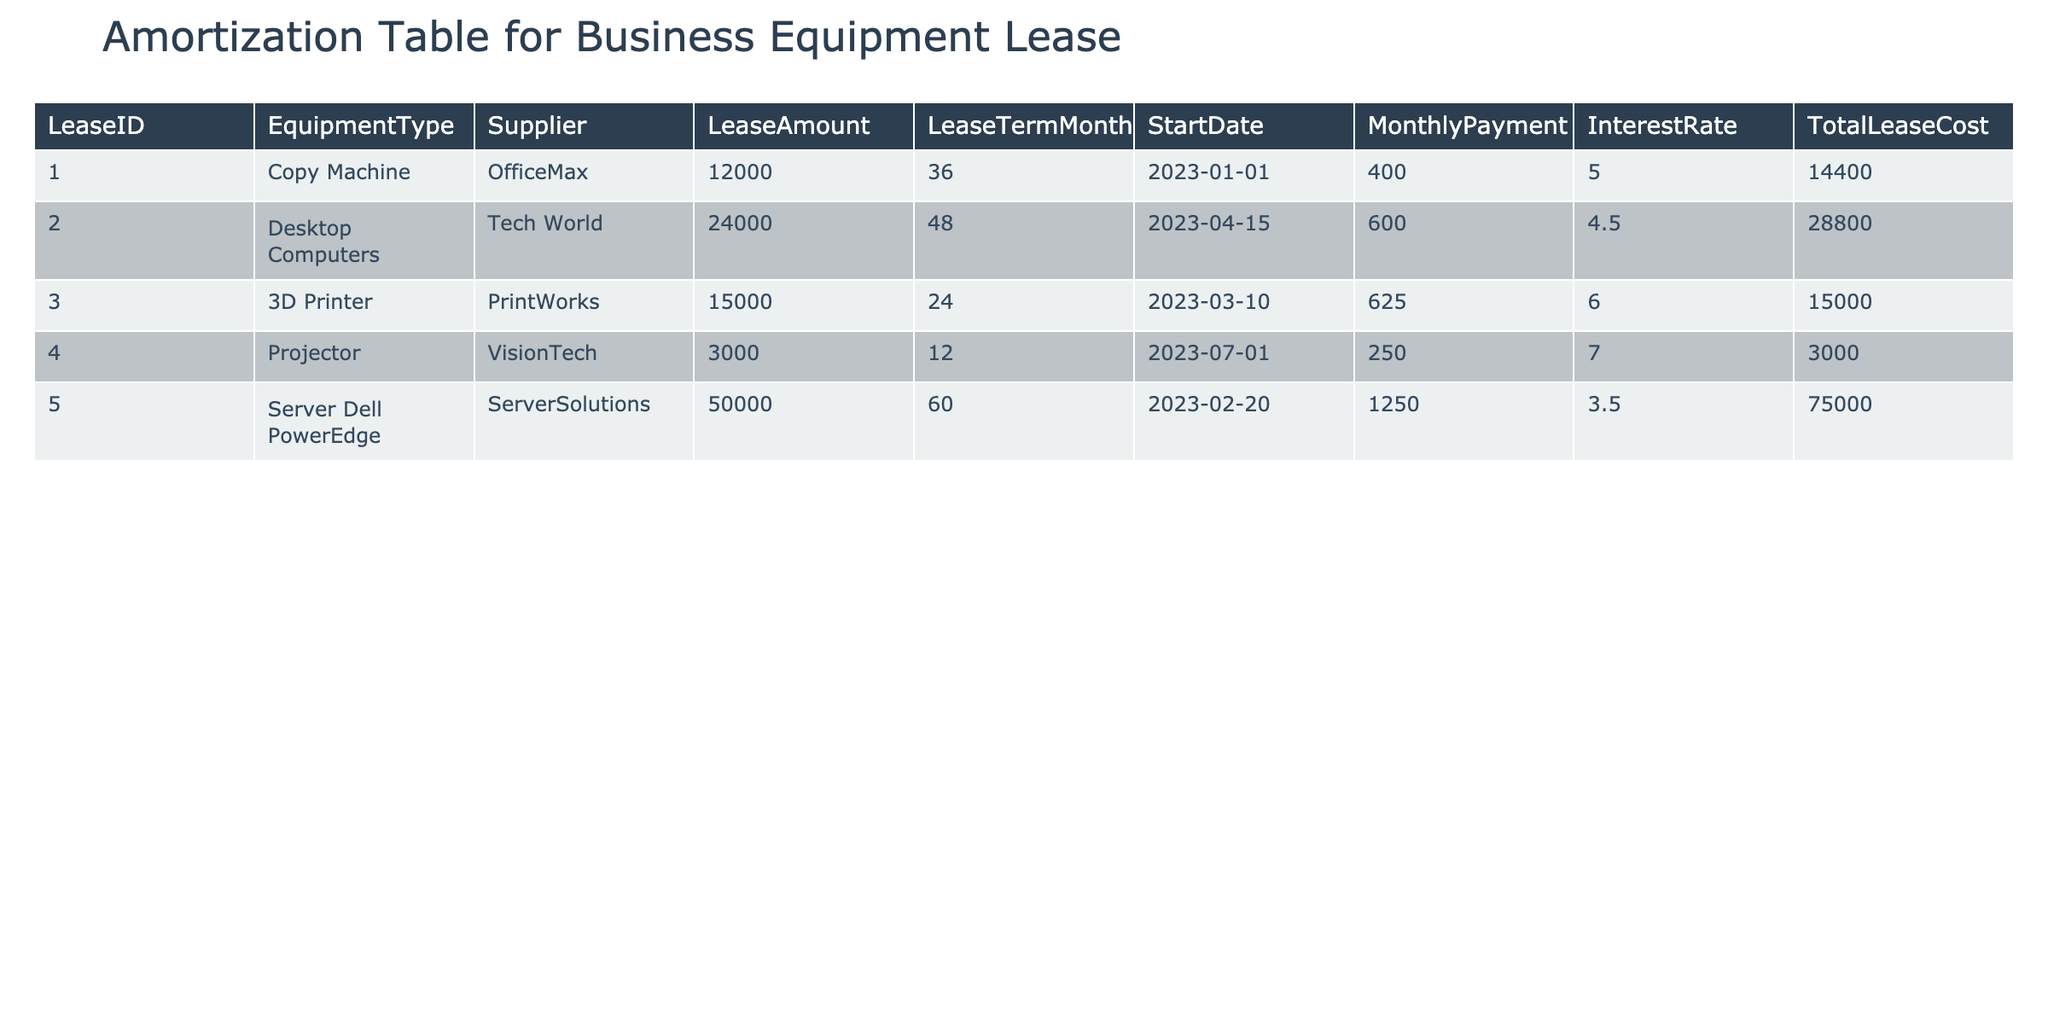What is the total lease cost for the Copy Machine? The total lease cost for the Copy Machine corresponds to LeaseID 1, which is specified in the table as 14400.
Answer: 14400 What is the monthly payment for the Server Dell PowerEdge lease? The monthly payment for the Server Dell PowerEdge is listed under LeaseID 5, which is 1250.
Answer: 1250 Which equipment type has the longest lease term? To find the longest lease term, we look through the LeaseTermMonths column. The maximum value is 60 months for the Server Dell PowerEdge.
Answer: Server Dell PowerEdge Is the interest rate for the Desktop Computers higher than 5%? The interest rate for the Desktop Computers, as per LeaseID 2, is 4.5%, which is less than 5%.
Answer: No What is the average monthly payment for all leases? First, we sum the monthly payments: 400 + 600 + 625 + 250 + 1250 = 3125. Then, divide by the number of leases, which is 5: 3125 / 5 = 625.
Answer: 625 How much total lease cost do the four items with the lowest total lease costs have? The items with the lowest total lease costs are the Projector (3000), the 3D Printer (15000), the Copy Machine (14400), and the Desktop Computers (28800). Adding these together: 3000 + 15000 + 14400 + 28800 = 61200.
Answer: 61200 Is the monthly payment for the equipment with the second highest total lease cost greater than 600? The total lease cost for each item shows that the Server Dell PowerEdge is the highest cost, and the second highest is Desktop Computers with a payment of 600. Since it is equal to 600, the answer is false.
Answer: No How many leases have a monthly payment less than 500? We check the MonthlyPayment column: Copy Machine (400), and Projector (250) are both less than 500. Thus, there are 2 leases fitting this criterion.
Answer: 2 Which supplier provided the equipment with the highest interest rate? The highest interest rate of 7% corresponds to the Projector with Supplier VisionTech. This is the maximum among the interest rates in the table.
Answer: VisionTech 